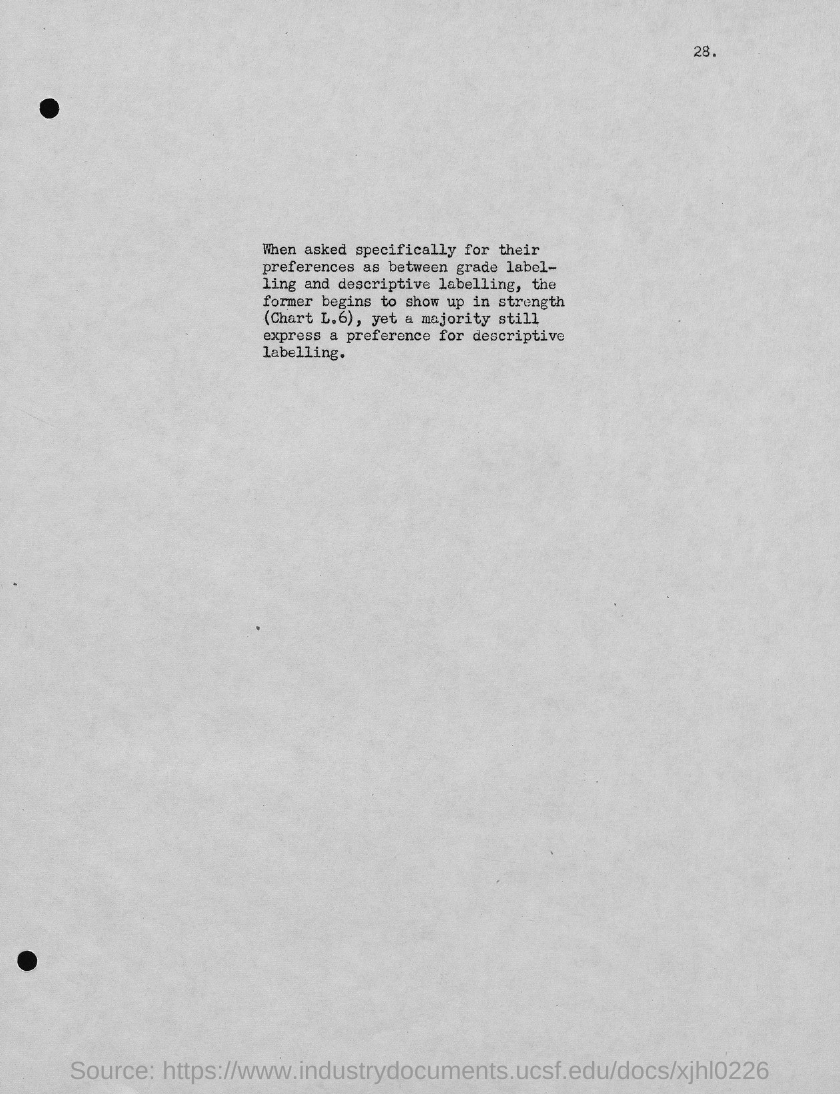Identify some key points in this picture. The page number is 28, as declared. 